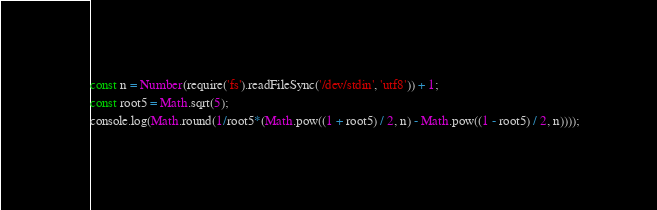<code> <loc_0><loc_0><loc_500><loc_500><_JavaScript_>const n = Number(require('fs').readFileSync('/dev/stdin', 'utf8')) + 1;
const root5 = Math.sqrt(5);
console.log(Math.round(1/root5*(Math.pow((1 + root5) / 2, n) - Math.pow((1 - root5) / 2, n))));

</code> 